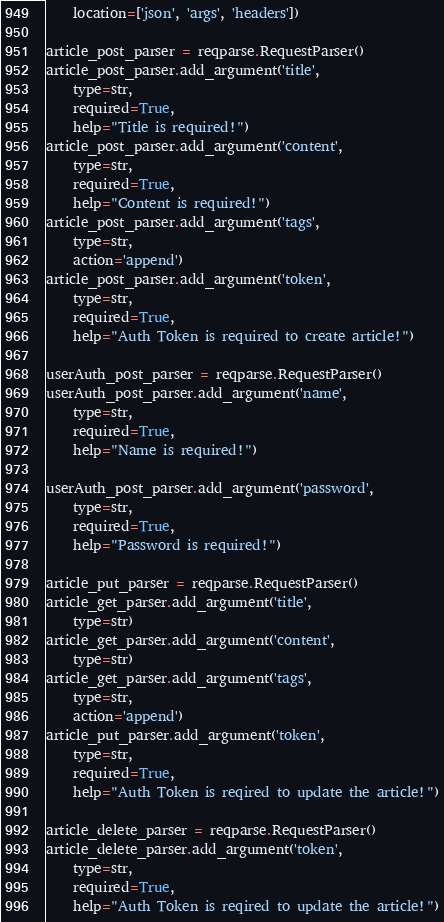Convert code to text. <code><loc_0><loc_0><loc_500><loc_500><_Python_>    location=['json', 'args', 'headers'])

article_post_parser = reqparse.RequestParser()
article_post_parser.add_argument('title',
    type=str,
    required=True,
    help="Title is required!")
article_post_parser.add_argument('content',
    type=str,
    required=True,
    help="Content is required!")
article_post_parser.add_argument('tags',
    type=str,
    action='append')
article_post_parser.add_argument('token',
    type=str,
    required=True,
    help="Auth Token is required to create article!")

userAuth_post_parser = reqparse.RequestParser()
userAuth_post_parser.add_argument('name',
    type=str,
    required=True,
    help="Name is required!")

userAuth_post_parser.add_argument('password',
    type=str,
    required=True,
    help="Password is required!")

article_put_parser = reqparse.RequestParser()
article_get_parser.add_argument('title',
    type=str)
article_get_parser.add_argument('content',
    type=str)
article_get_parser.add_argument('tags',
    type=str,
    action='append')
article_put_parser.add_argument('token',
    type=str,
    required=True,
    help="Auth Token is reqired to update the article!")

article_delete_parser = reqparse.RequestParser()
article_delete_parser.add_argument('token',
    type=str,
    required=True,
    help="Auth Token is reqired to update the article!")

</code> 